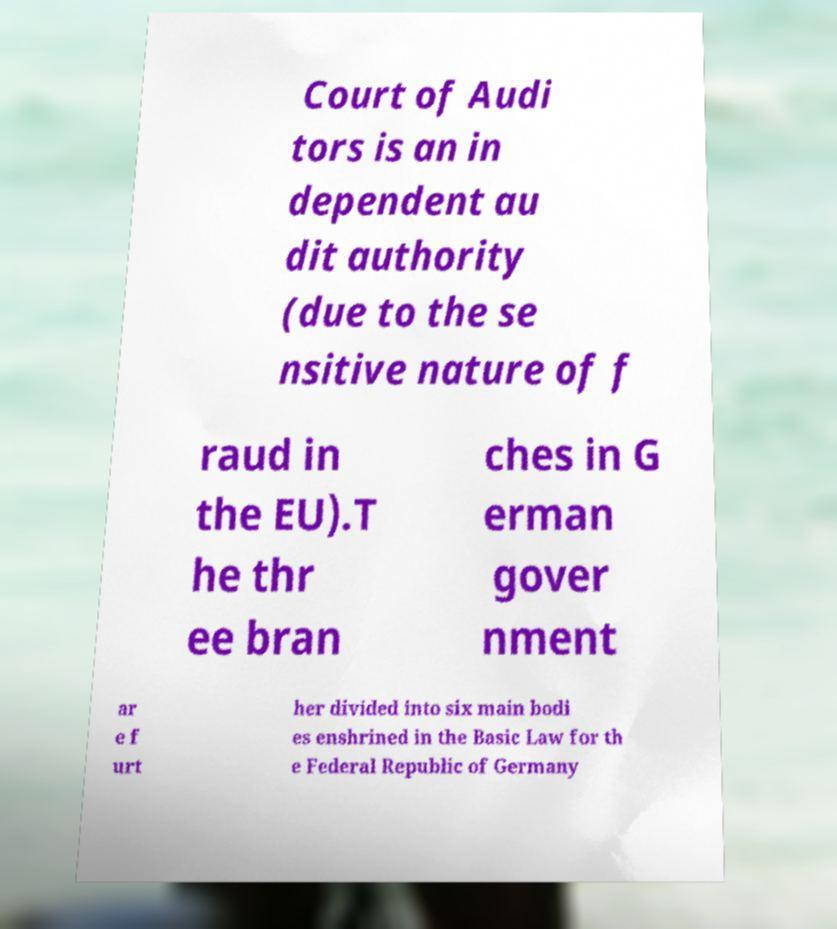Please read and relay the text visible in this image. What does it say? Court of Audi tors is an in dependent au dit authority (due to the se nsitive nature of f raud in the EU).T he thr ee bran ches in G erman gover nment ar e f urt her divided into six main bodi es enshrined in the Basic Law for th e Federal Republic of Germany 